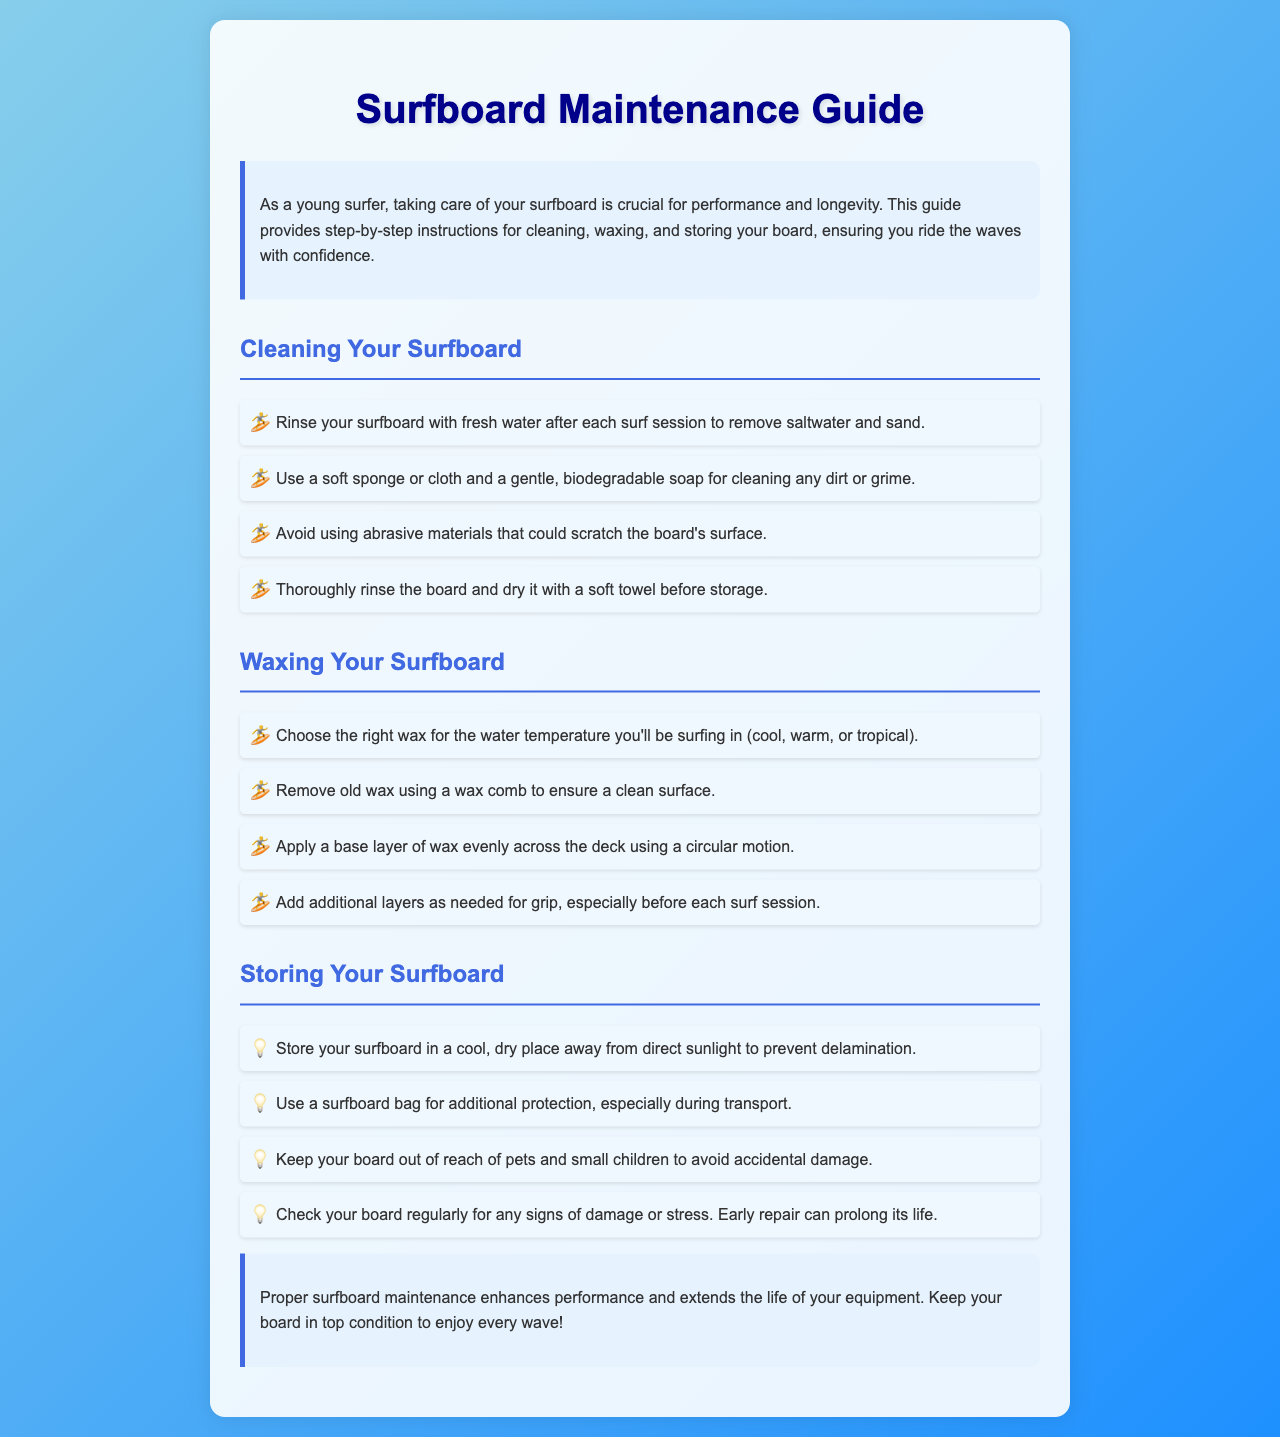what is the purpose of the guide? The guide provides step-by-step instructions for cleaning, waxing, and storing your board, ensuring you ride the waves with confidence.
Answer: performance and longevity how should you clean your surfboard? The document lists specific steps for cleaning, including rinsing and using a soft sponge or cloth.
Answer: rinse with fresh water what type of soap should be used for cleaning? The document specifically mentions the type of soap that is recommended.
Answer: biodegradable soap what should you do with old wax? The guide advises on the proper way to handle old wax before applying new wax.
Answer: remove with a wax comb how can you ensure your surfboard has a good grip? The document mentions the application method to achieve grip.
Answer: apply additional layers of wax where should you store your surfboard? The recommendation for storage emphasizes conditions that prevent damage.
Answer: cool, dry place what should be checked regularly on the surfboard? The document suggests routine checks for specific signs to prolong the board's life.
Answer: signs of damage or stress what should be used for protection during transport? The guide provides a suggestion for added protection while carrying the surfboard.
Answer: surfboard bag what is the best practice after a surf session? The manual provides a step to follow immediately after surfing to care for the board.
Answer: rinse your surfboard 